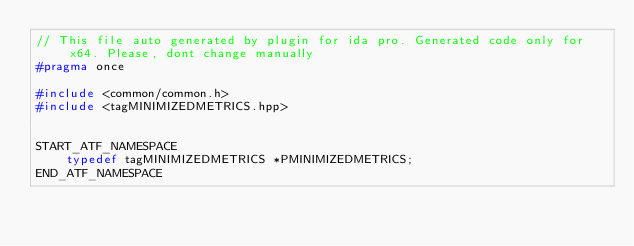Convert code to text. <code><loc_0><loc_0><loc_500><loc_500><_C++_>// This file auto generated by plugin for ida pro. Generated code only for x64. Please, dont change manually
#pragma once

#include <common/common.h>
#include <tagMINIMIZEDMETRICS.hpp>


START_ATF_NAMESPACE
    typedef tagMINIMIZEDMETRICS *PMINIMIZEDMETRICS;
END_ATF_NAMESPACE
</code> 